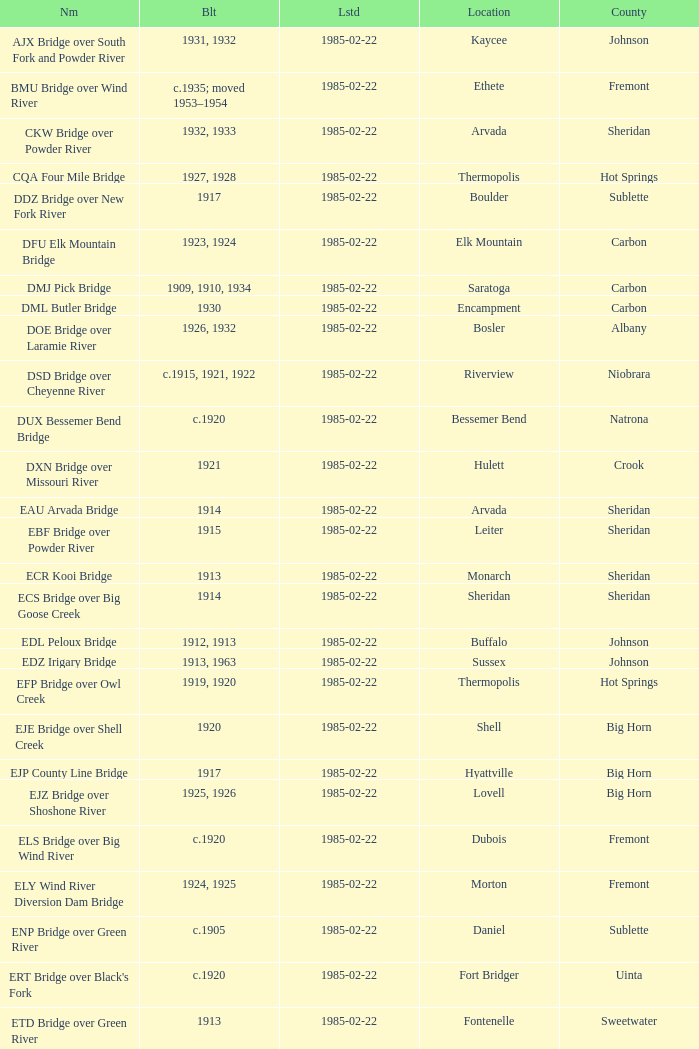What bridge in Sheridan county was built in 1915? EBF Bridge over Powder River. 